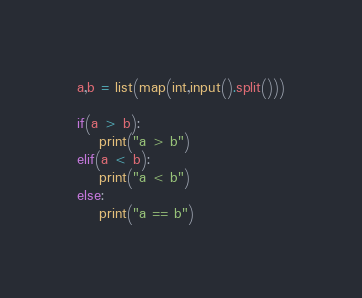<code> <loc_0><loc_0><loc_500><loc_500><_Python_>a,b = list(map(int,input().split()))

if(a > b):
    print("a > b")
elif(a < b):
    print("a < b")
else:
    print("a == b")
</code> 